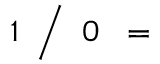<formula> <loc_0><loc_0><loc_500><loc_500>\, 1 \, { \Big / } \, 0 \, =</formula> 